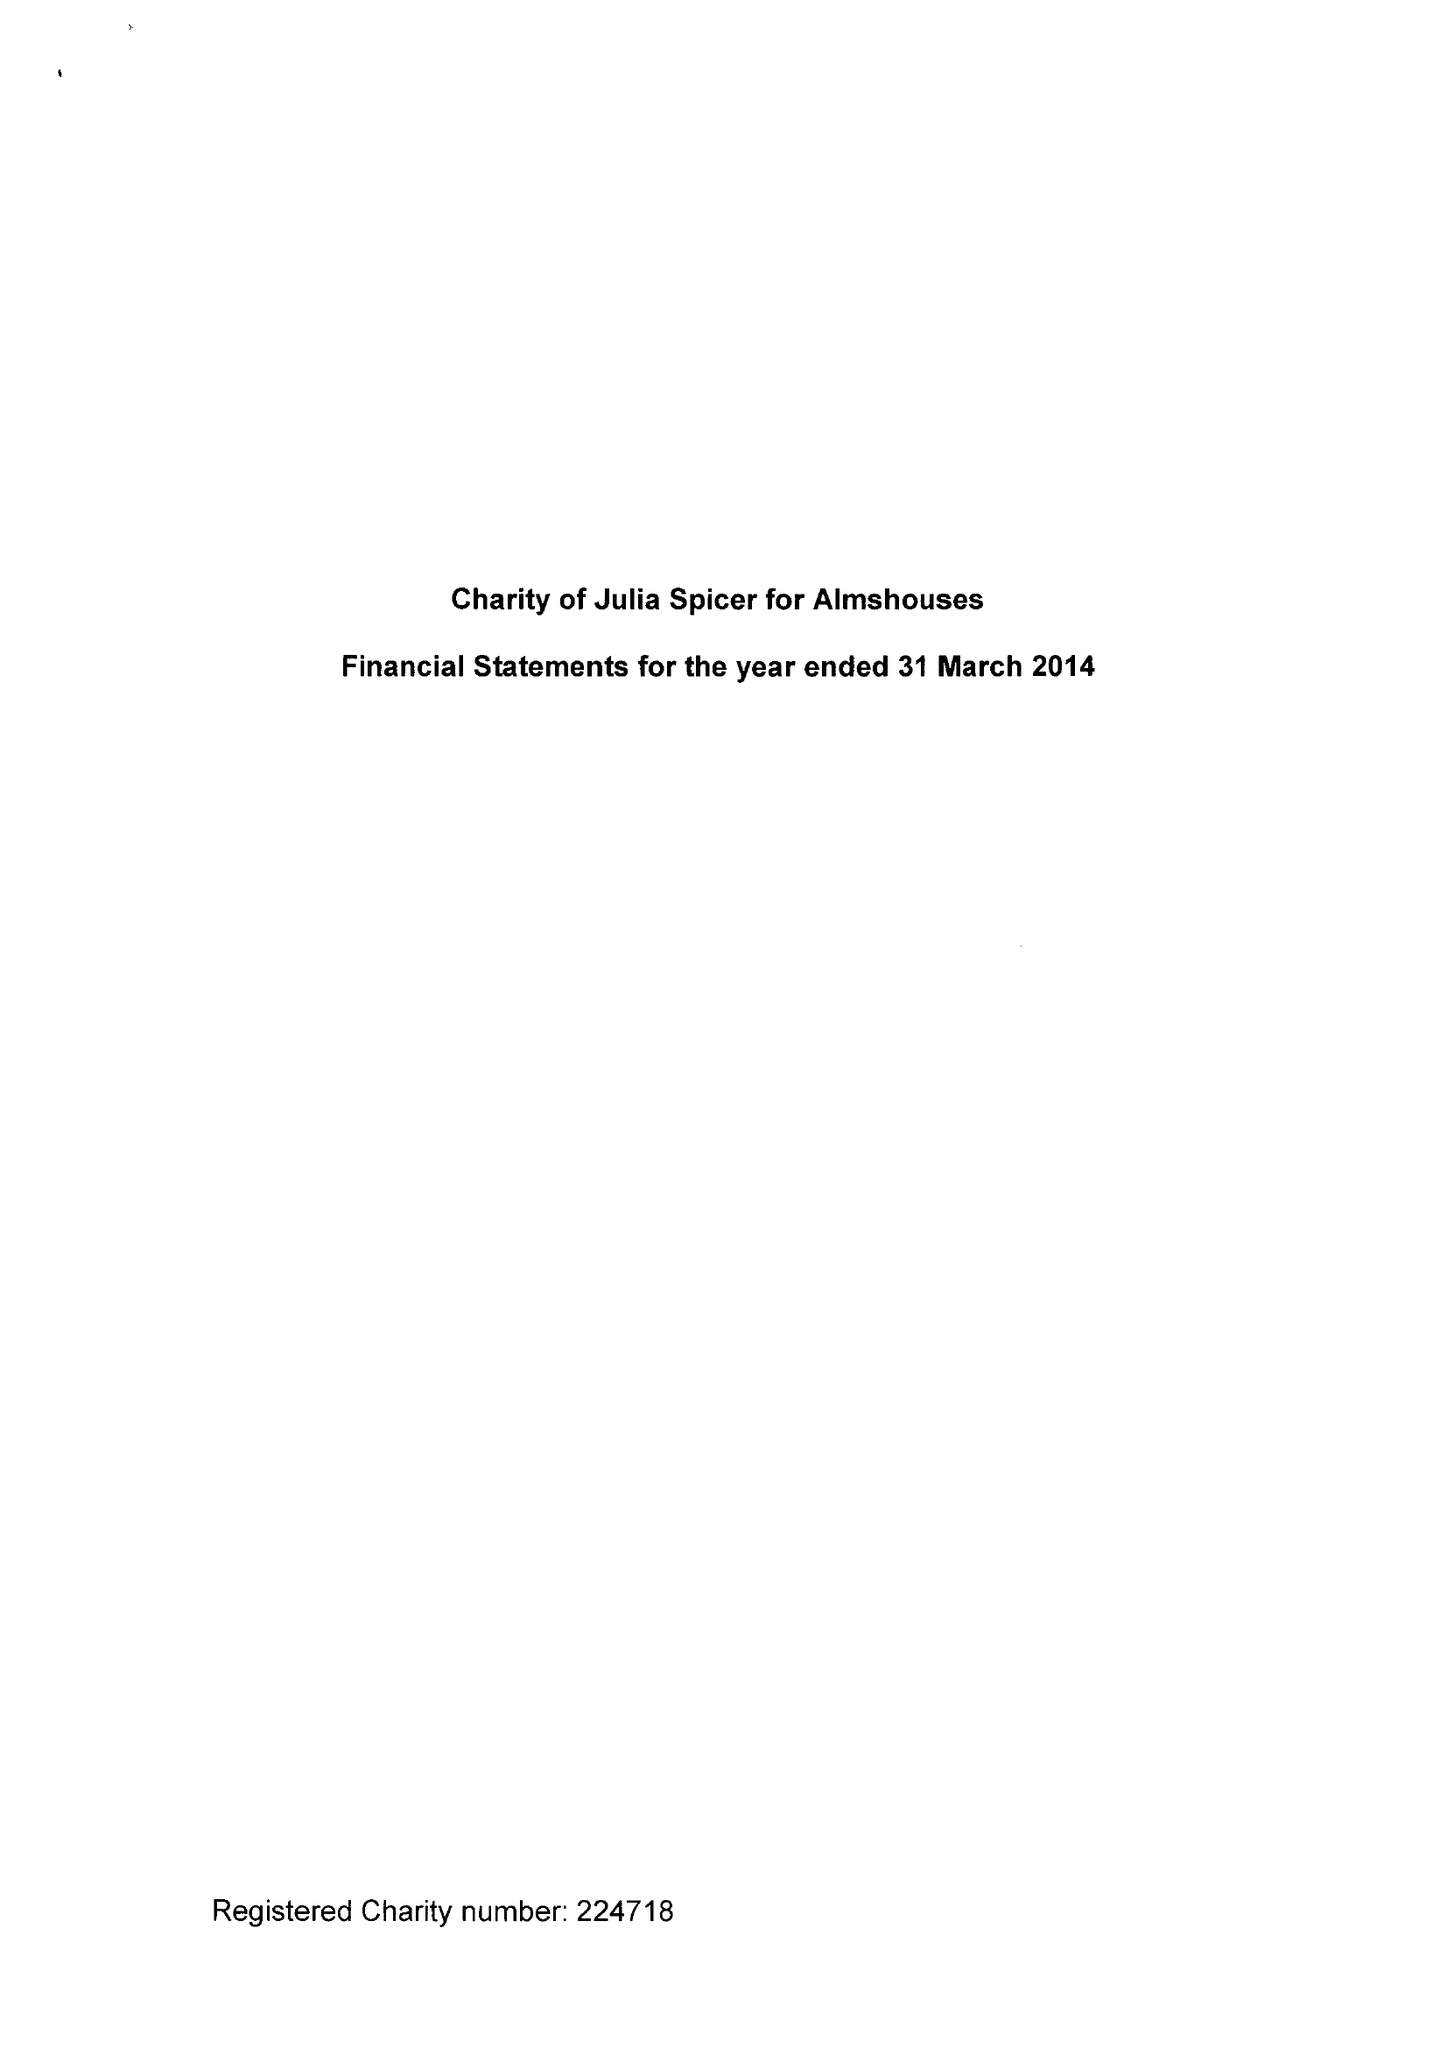What is the value for the charity_number?
Answer the question using a single word or phrase. 224718 